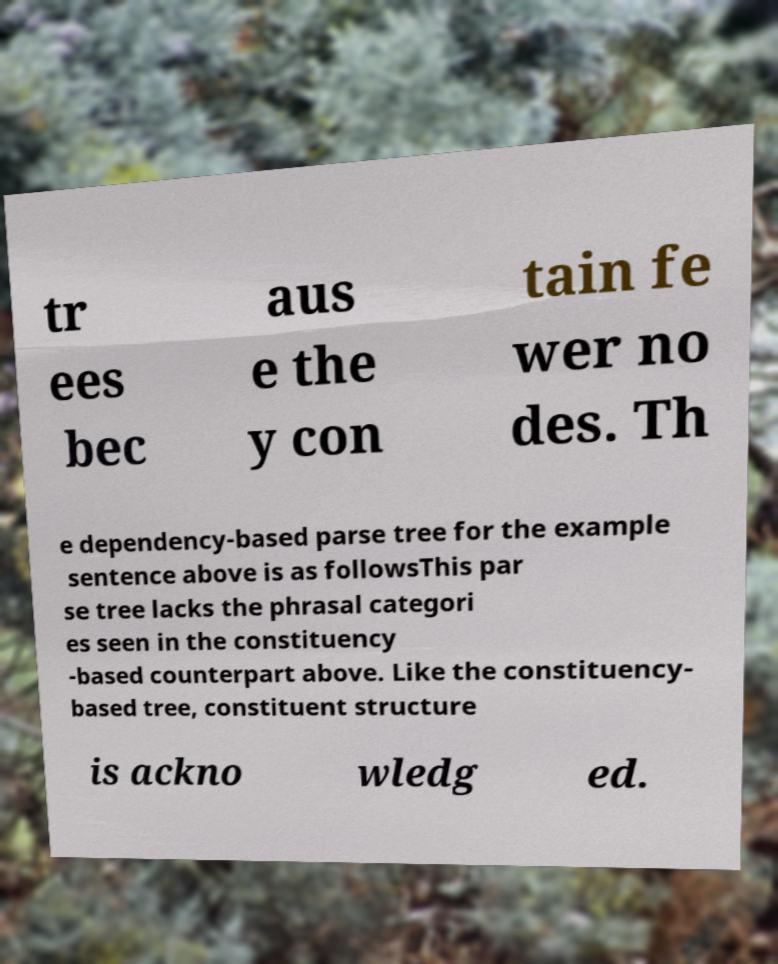I need the written content from this picture converted into text. Can you do that? tr ees bec aus e the y con tain fe wer no des. Th e dependency-based parse tree for the example sentence above is as followsThis par se tree lacks the phrasal categori es seen in the constituency -based counterpart above. Like the constituency- based tree, constituent structure is ackno wledg ed. 